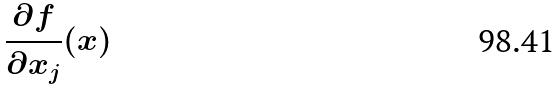Convert formula to latex. <formula><loc_0><loc_0><loc_500><loc_500>\frac { \partial f } { \partial x _ { j } } ( x )</formula> 